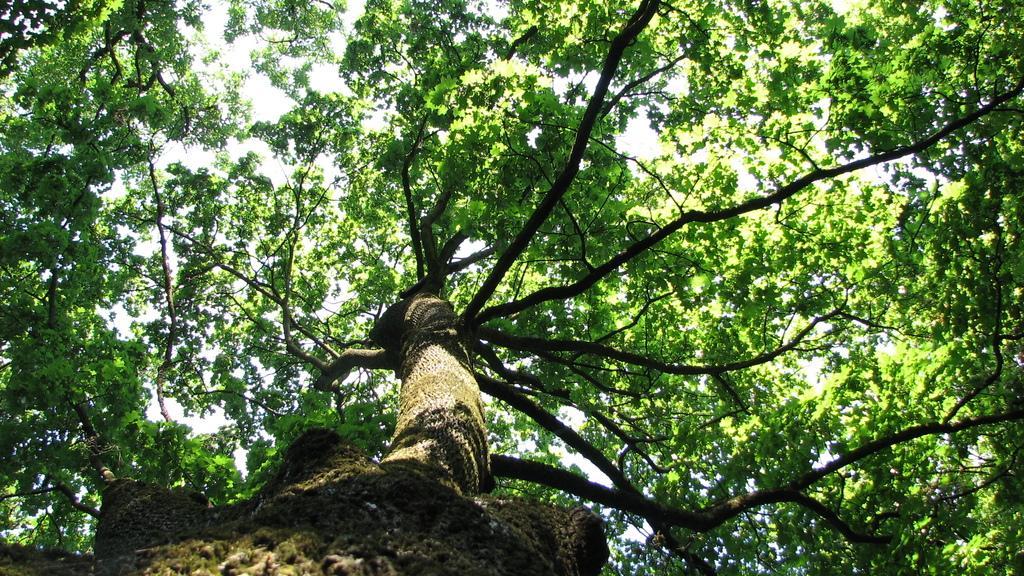How would you summarize this image in a sentence or two? In this image there is a tree trunk in the middle. At the top there are green leaves with the stems and branches. 